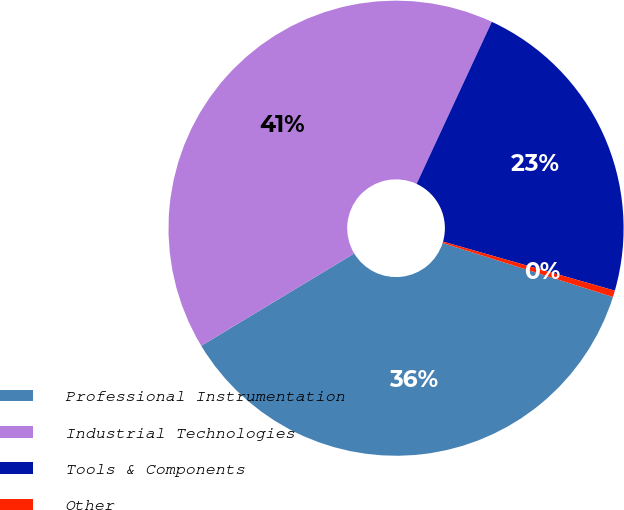<chart> <loc_0><loc_0><loc_500><loc_500><pie_chart><fcel>Professional Instrumentation<fcel>Industrial Technologies<fcel>Tools & Components<fcel>Other<nl><fcel>36.47%<fcel>40.56%<fcel>22.51%<fcel>0.46%<nl></chart> 